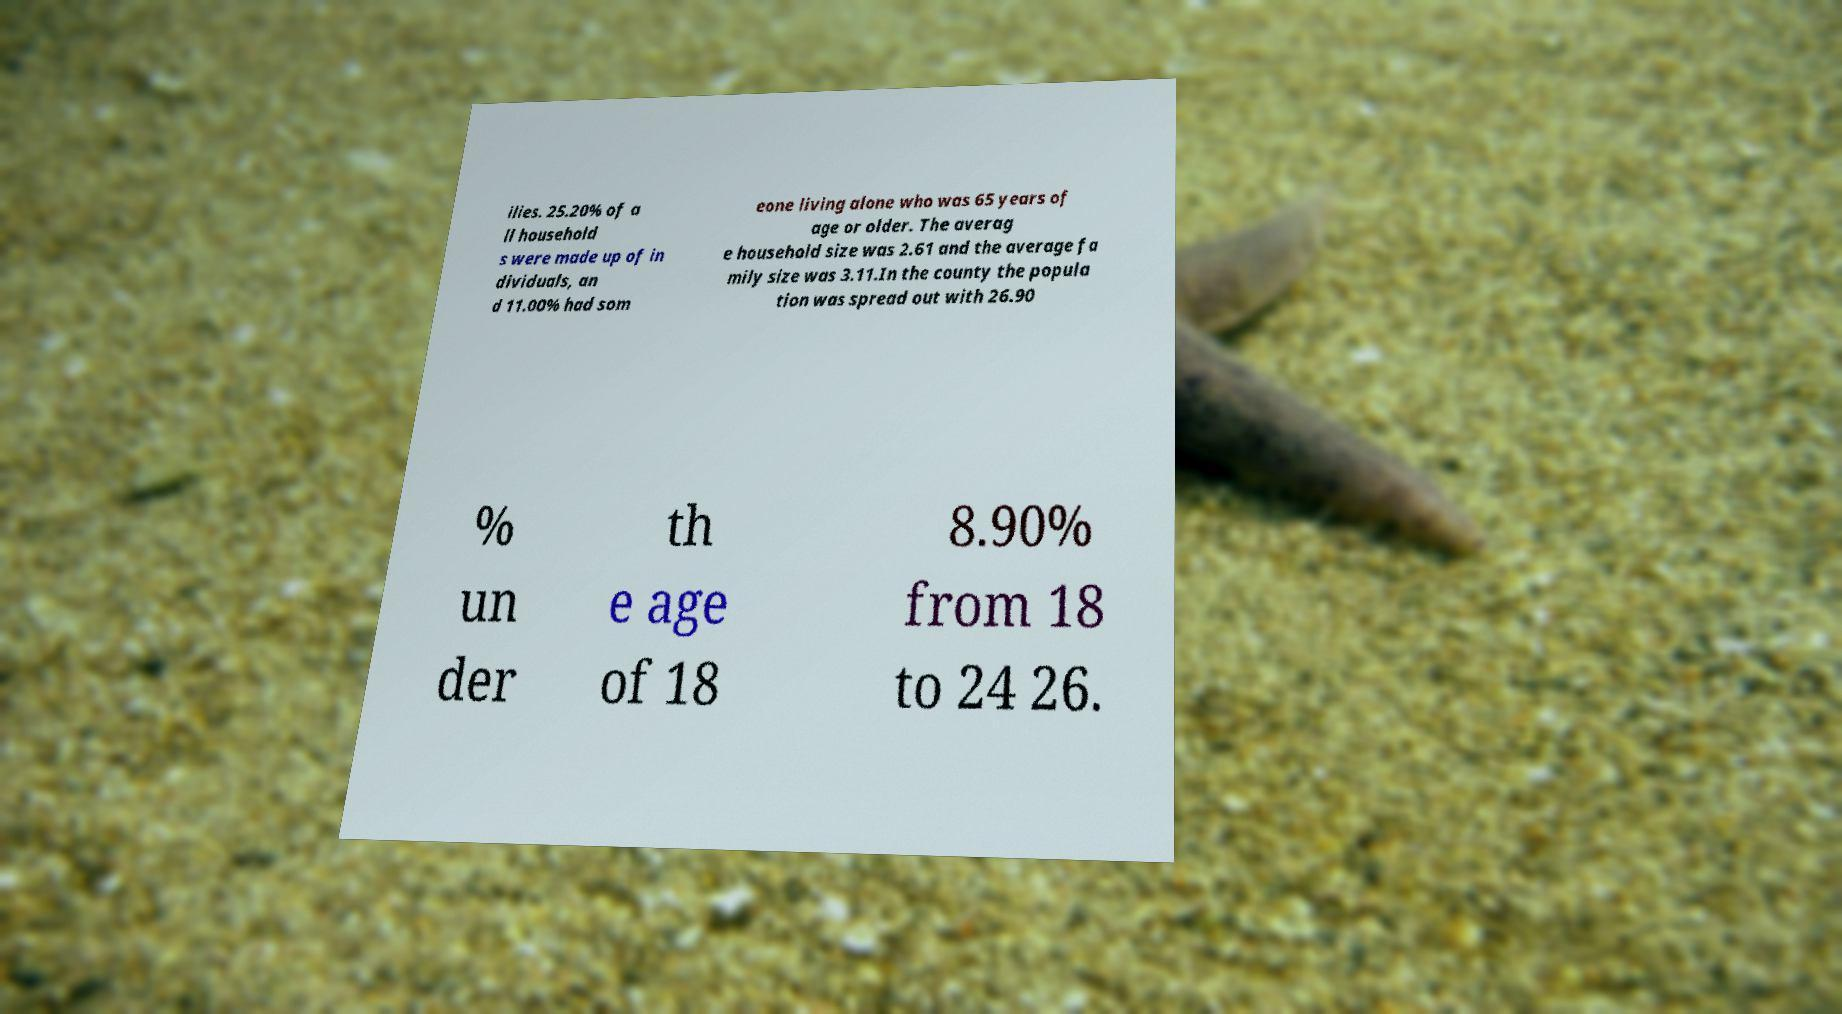What messages or text are displayed in this image? I need them in a readable, typed format. ilies. 25.20% of a ll household s were made up of in dividuals, an d 11.00% had som eone living alone who was 65 years of age or older. The averag e household size was 2.61 and the average fa mily size was 3.11.In the county the popula tion was spread out with 26.90 % un der th e age of 18 8.90% from 18 to 24 26. 